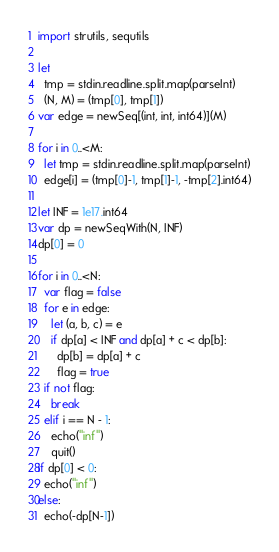<code> <loc_0><loc_0><loc_500><loc_500><_Nim_>import strutils, sequtils

let
  tmp = stdin.readline.split.map(parseInt)
  (N, M) = (tmp[0], tmp[1])
var edge = newSeq[(int, int, int64)](M)

for i in 0..<M:
  let tmp = stdin.readline.split.map(parseInt)
  edge[i] = (tmp[0]-1, tmp[1]-1, -tmp[2].int64)

let INF = 1e17.int64
var dp = newSeqWith(N, INF)
dp[0] = 0

for i in 0..<N:
  var flag = false
  for e in edge:
    let (a, b, c) = e
    if dp[a] < INF and dp[a] + c < dp[b]:
      dp[b] = dp[a] + c
      flag = true
  if not flag:
    break
  elif i == N - 1:
    echo("inf")
    quit()
if dp[0] < 0:
  echo("inf")
else:
  echo(-dp[N-1])
</code> 